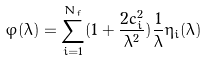Convert formula to latex. <formula><loc_0><loc_0><loc_500><loc_500>\varphi ( \lambda ) = \sum _ { i = 1 } ^ { N _ { f } } ( 1 + \frac { 2 c _ { i } ^ { 2 } } { \lambda ^ { 2 } } ) \frac { 1 } { \lambda } \eta _ { i } ( \lambda )</formula> 